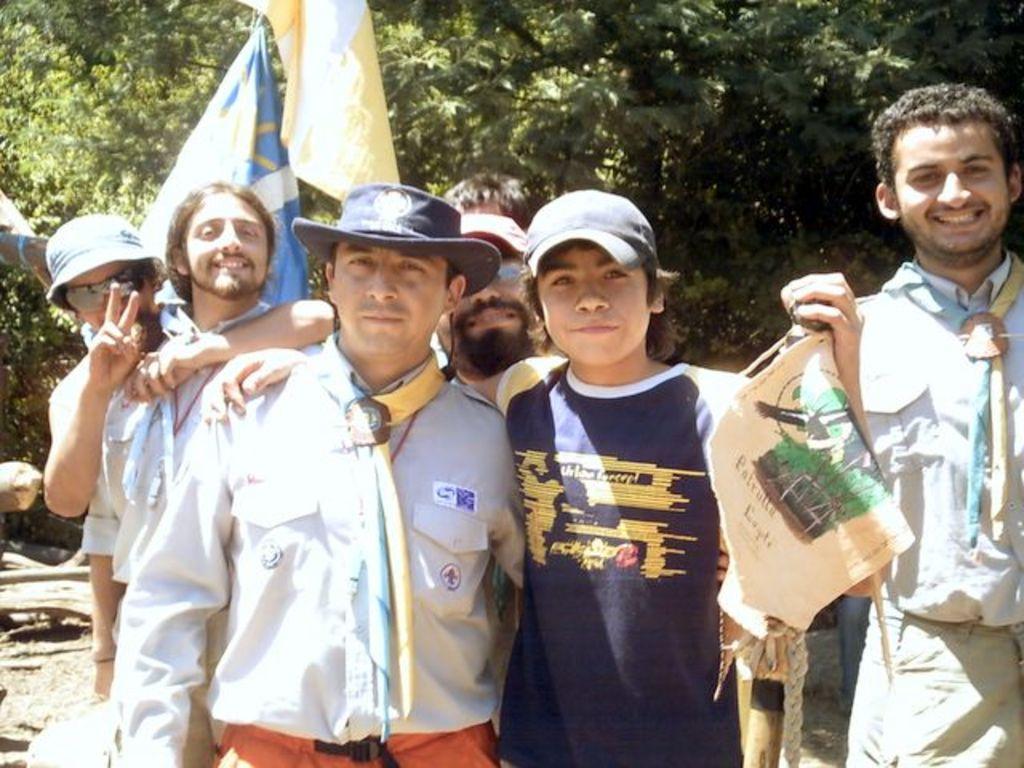Could you give a brief overview of what you see in this image? In this image there are a few people standing with a smile on their face are posing for a picture, behind them there are trees and flags. 